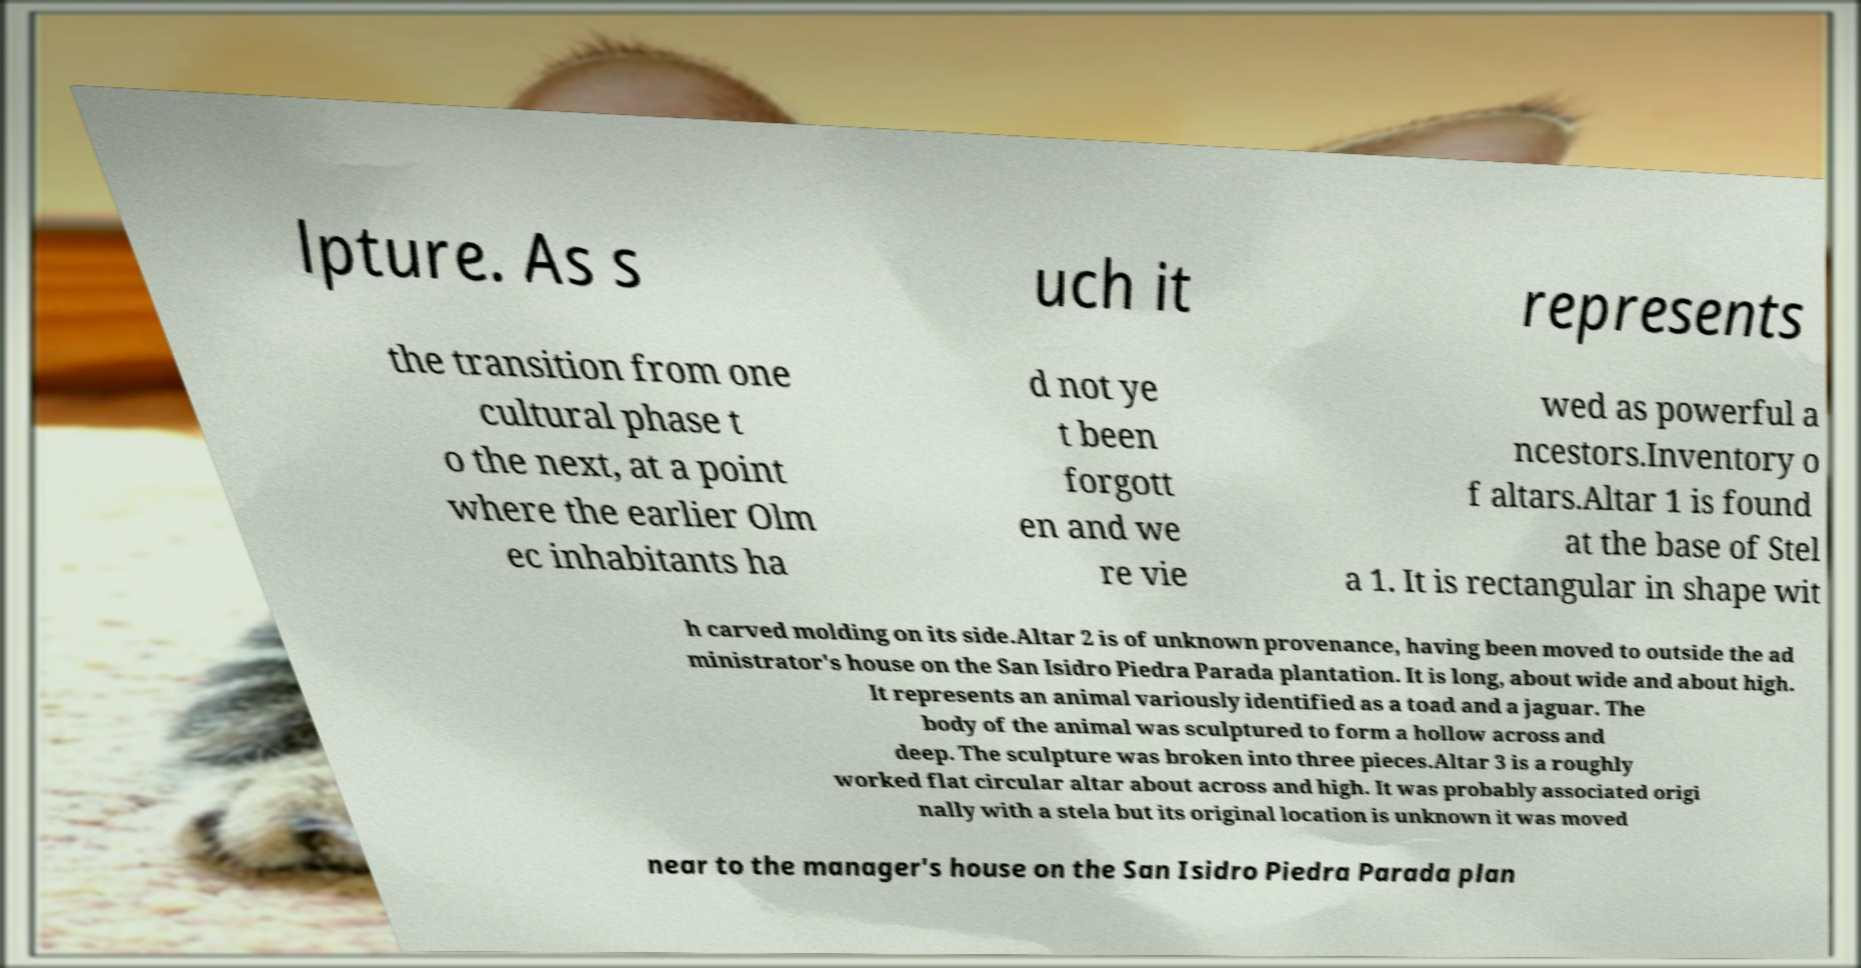Please read and relay the text visible in this image. What does it say? lpture. As s uch it represents the transition from one cultural phase t o the next, at a point where the earlier Olm ec inhabitants ha d not ye t been forgott en and we re vie wed as powerful a ncestors.Inventory o f altars.Altar 1 is found at the base of Stel a 1. It is rectangular in shape wit h carved molding on its side.Altar 2 is of unknown provenance, having been moved to outside the ad ministrator's house on the San Isidro Piedra Parada plantation. It is long, about wide and about high. It represents an animal variously identified as a toad and a jaguar. The body of the animal was sculptured to form a hollow across and deep. The sculpture was broken into three pieces.Altar 3 is a roughly worked flat circular altar about across and high. It was probably associated origi nally with a stela but its original location is unknown it was moved near to the manager's house on the San Isidro Piedra Parada plan 